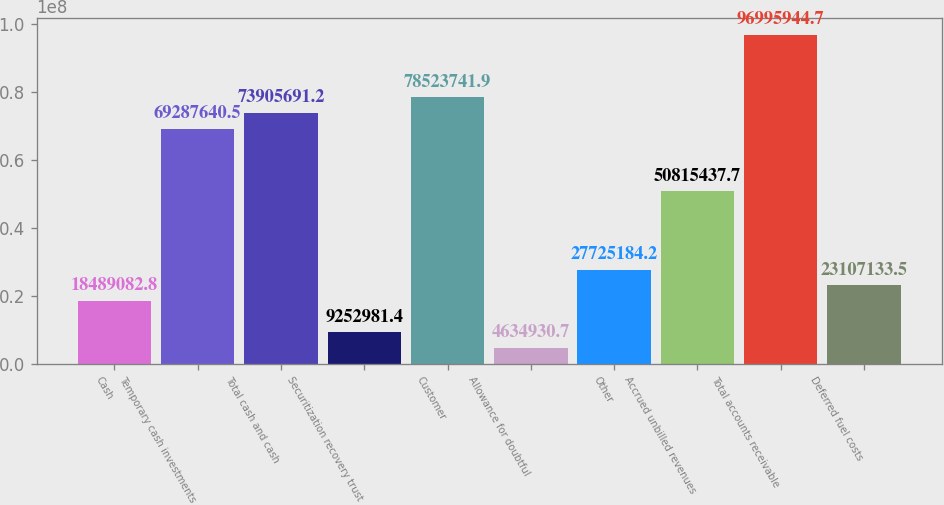Convert chart. <chart><loc_0><loc_0><loc_500><loc_500><bar_chart><fcel>Cash<fcel>Temporary cash investments<fcel>Total cash and cash<fcel>Securitization recovery trust<fcel>Customer<fcel>Allowance for doubtful<fcel>Other<fcel>Accrued unbilled revenues<fcel>Total accounts receivable<fcel>Deferred fuel costs<nl><fcel>1.84891e+07<fcel>6.92876e+07<fcel>7.39057e+07<fcel>9.25298e+06<fcel>7.85237e+07<fcel>4.63493e+06<fcel>2.77252e+07<fcel>5.08154e+07<fcel>9.69959e+07<fcel>2.31071e+07<nl></chart> 